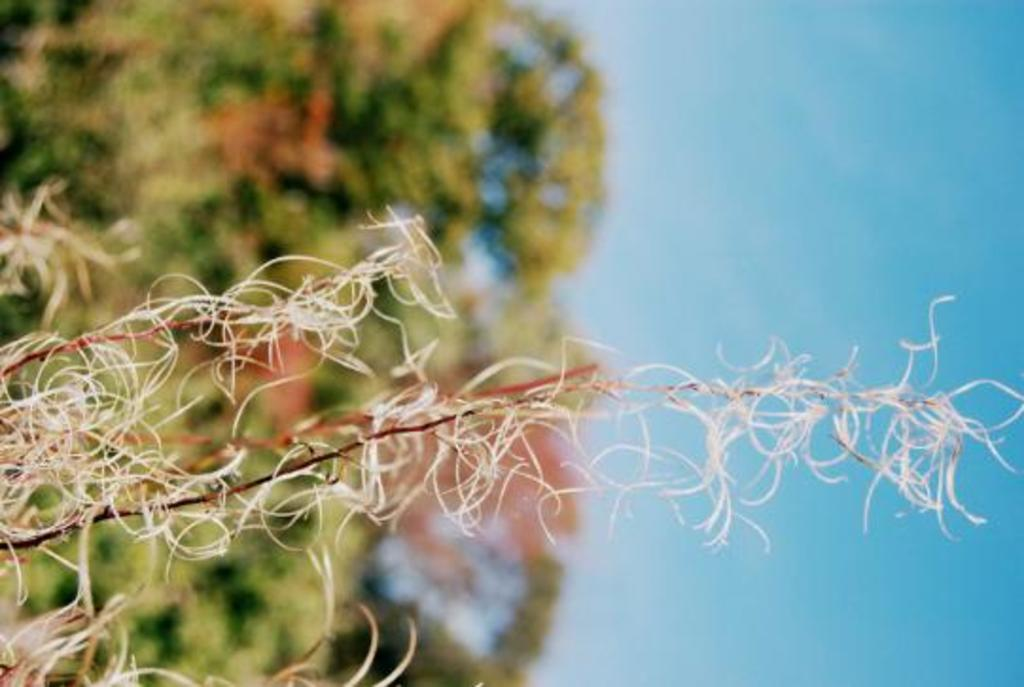What is present in the image? There is a plant in the image. What can be seen in the background of the image? The background of the image contains greenery. What part of the natural environment is visible in the image? The sky is visible in the image. How many trucks are visible in the image? There are no trucks present in the image. What type of knife can be seen in the image? There is no knife present in the image. 